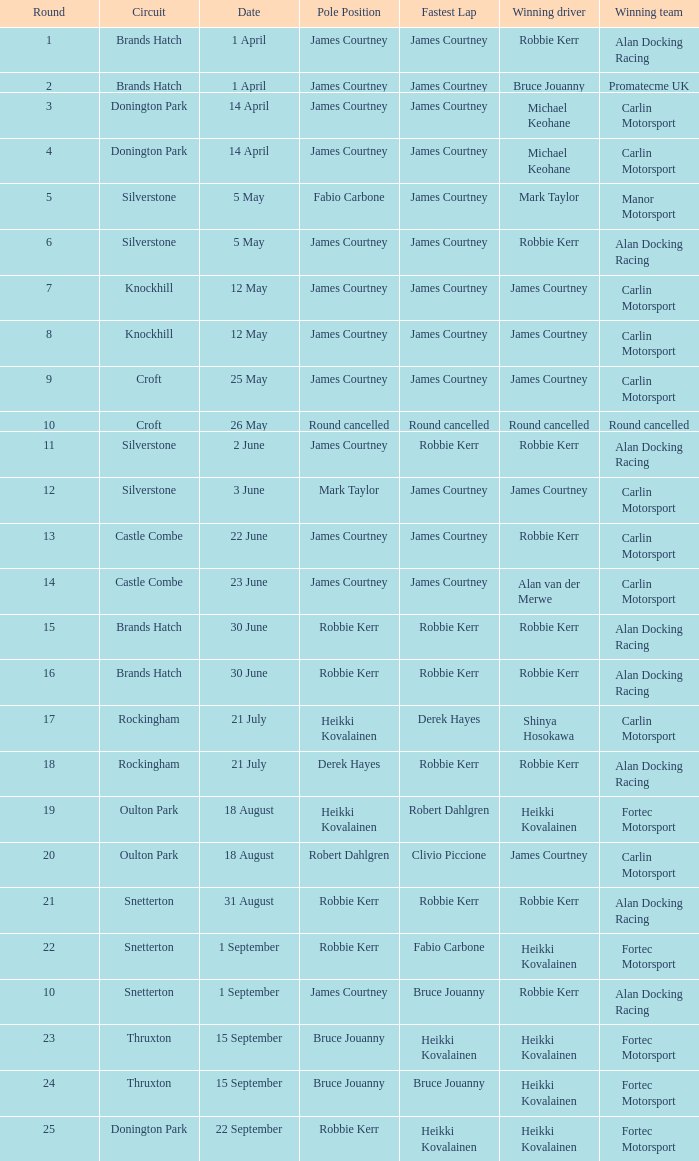What is every starting position at the castle combe circuit when robbie kerr is the successful driver? James Courtney. 